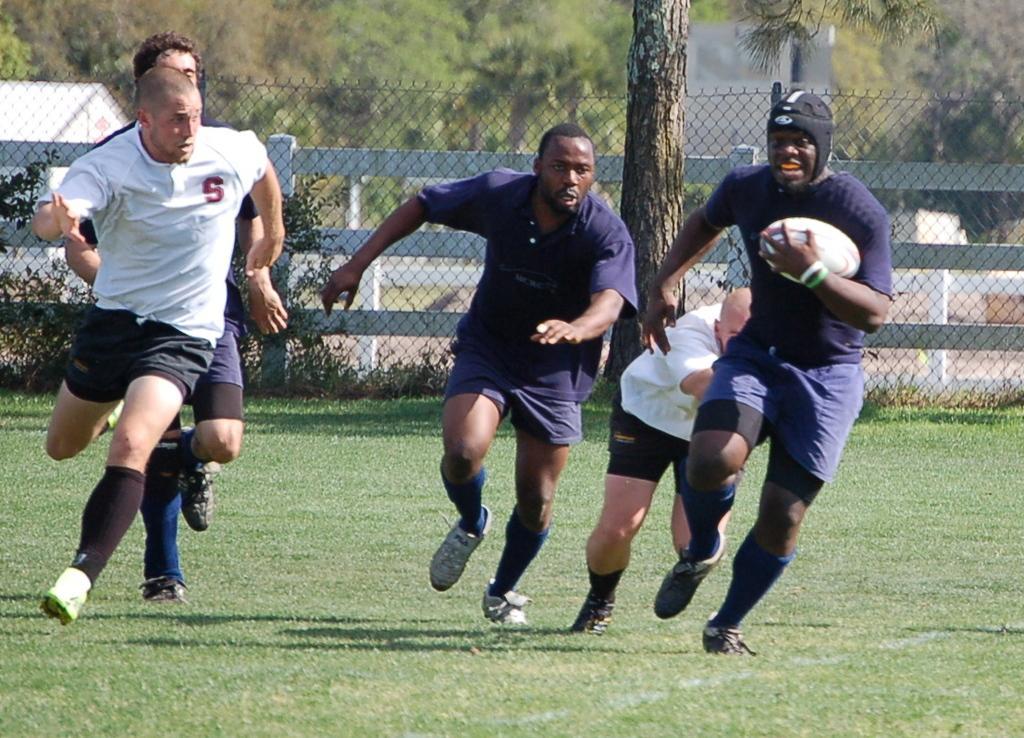Could you give a brief overview of what you see in this image? This image there is a playground visible. And there is fence and there are some trees visible and there are some players playing a ball and they are running. 